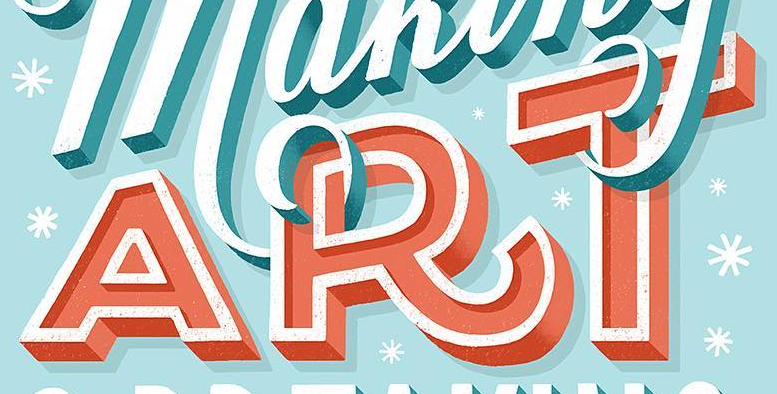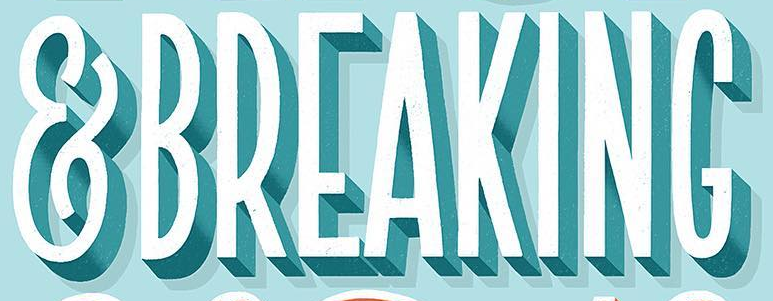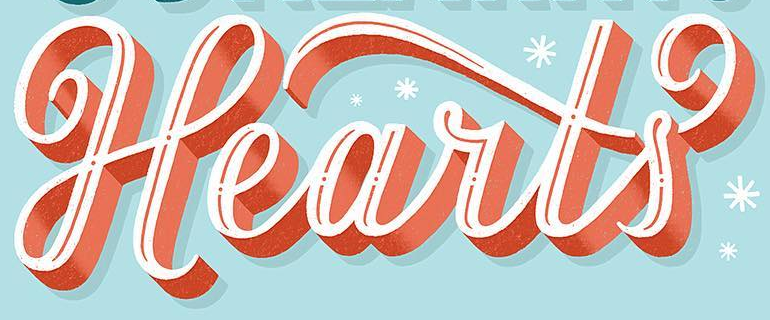What text is displayed in these images sequentially, separated by a semicolon? ART; &BREAKING; Hearts 